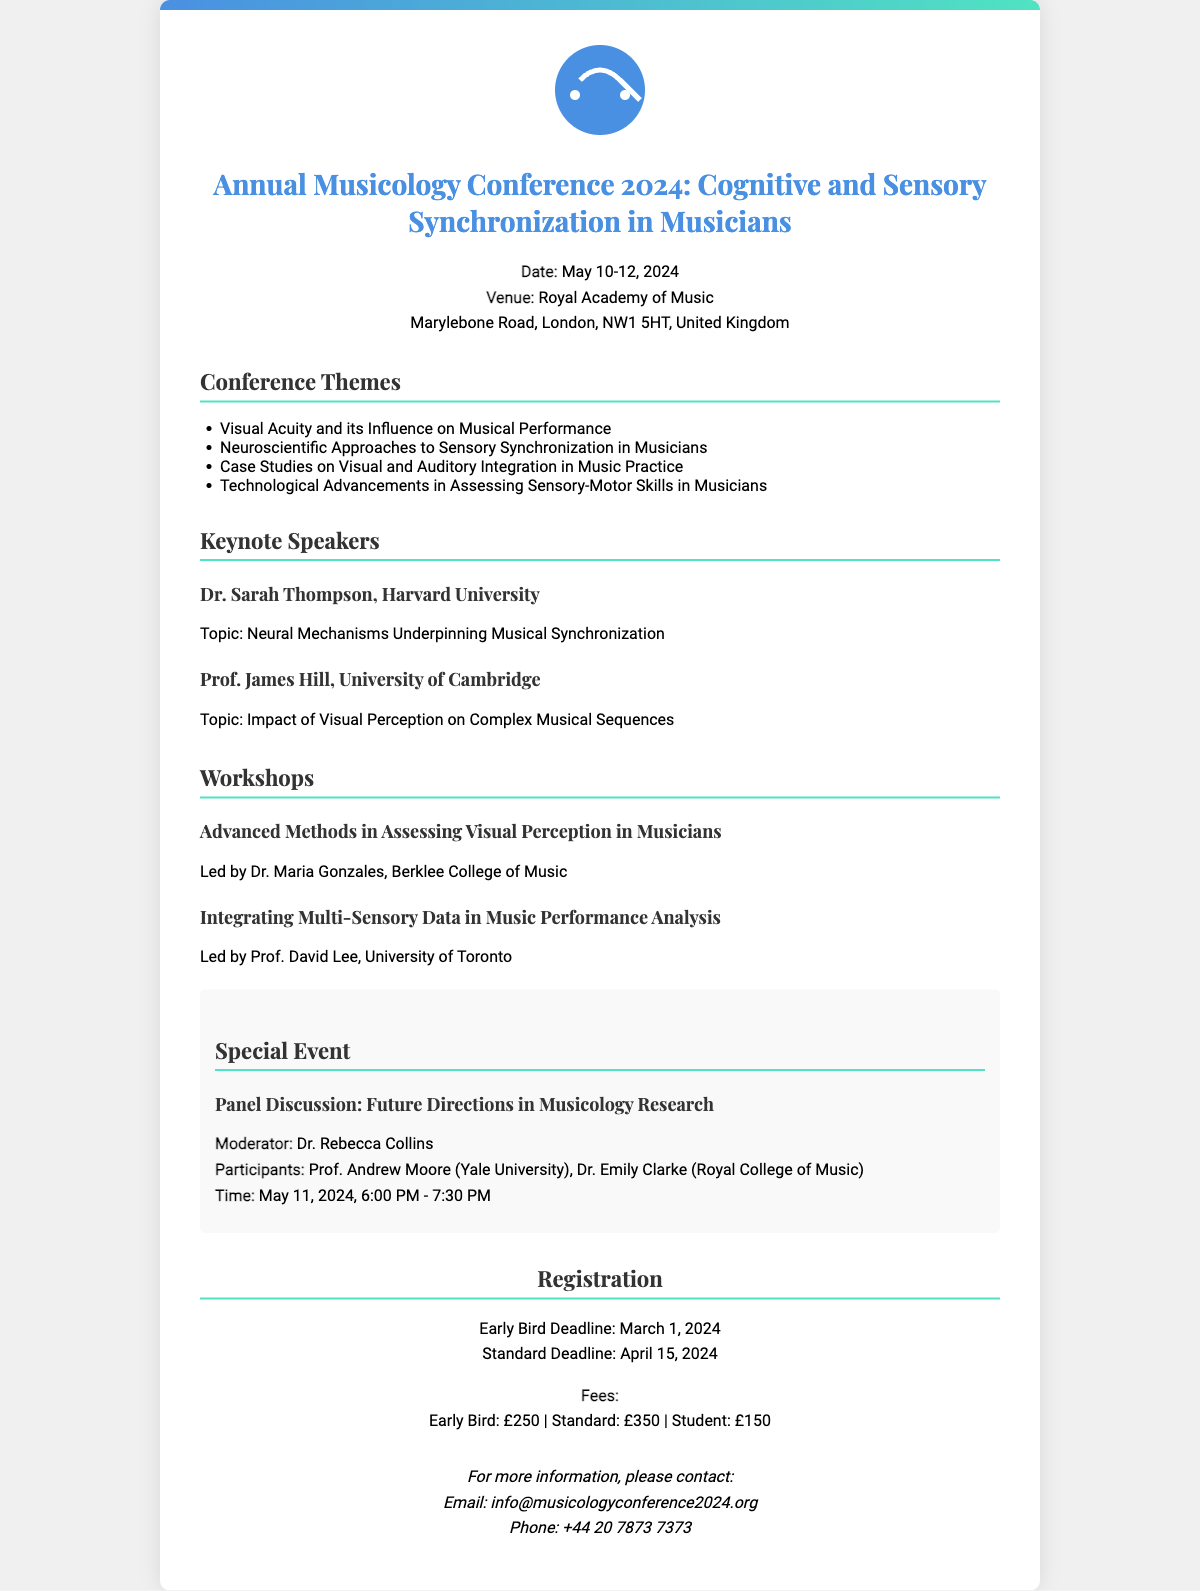What are the conference dates? The document specifies the dates of the conference, which are May 10-12, 2024.
Answer: May 10-12, 2024 Who is the keynote speaker from Harvard University? Dr. Sarah Thompson is mentioned as the keynote speaker associated with Harvard University.
Answer: Dr. Sarah Thompson What is the registration deadline for early bird fees? The document indicates that the early bird registration deadline is March 1, 2024.
Answer: March 1, 2024 What is the fee for standard registration? The document details that the standard registration fee is £350.
Answer: £350 What is the venue of the conference? The invitation specifies the venue as the Royal Academy of Music, London.
Answer: Royal Academy of Music Which workshop focuses on assessing visual perception? The document states that there is a workshop titled "Advanced Methods in Assessing Visual Perception in Musicians."
Answer: Advanced Methods in Assessing Visual Perception in Musicians What special event is mentioned in the document? The document describes a panel discussion as a special event, focusing on future directions in musicology research.
Answer: Panel Discussion: Future Directions in Musicology Research Who is moderating the special event? The document specifies that Dr. Rebecca Collins will be the moderator for the panel discussion.
Answer: Dr. Rebecca Collins 